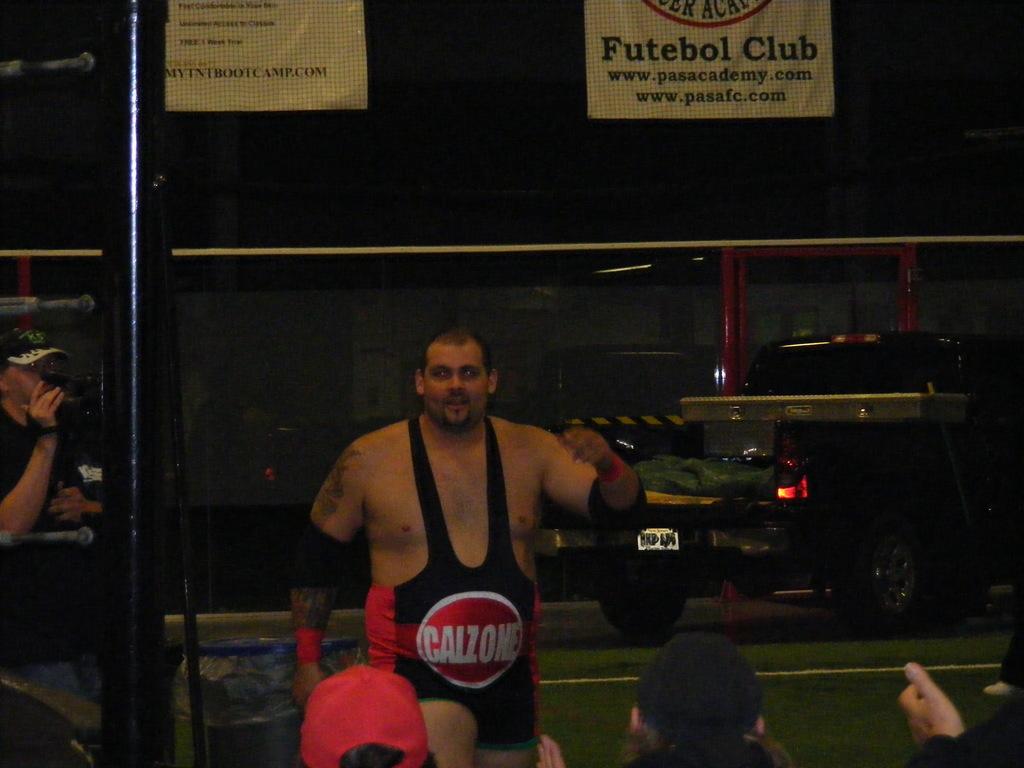What does the fighters logo say?
Keep it short and to the point. Calzone. What sport is that?
Offer a terse response. Futebol. 